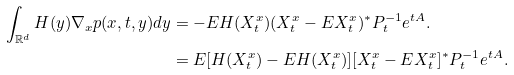Convert formula to latex. <formula><loc_0><loc_0><loc_500><loc_500>\int _ { \mathbb { R } ^ { d } } H ( y ) \nabla _ { x } p ( x , t , y ) d y & = - E H ( X ^ { x } _ { t } ) ( X ^ { x } _ { t } - E X ^ { x } _ { t } ) ^ { * } P ^ { - 1 } _ { t } e ^ { t A } . \\ & = E [ H ( X ^ { x } _ { t } ) - E H ( X ^ { x } _ { t } ) ] [ X ^ { x } _ { t } - E X ^ { x } _ { t } ] ^ { * } P ^ { - 1 } _ { t } e ^ { t A } .</formula> 